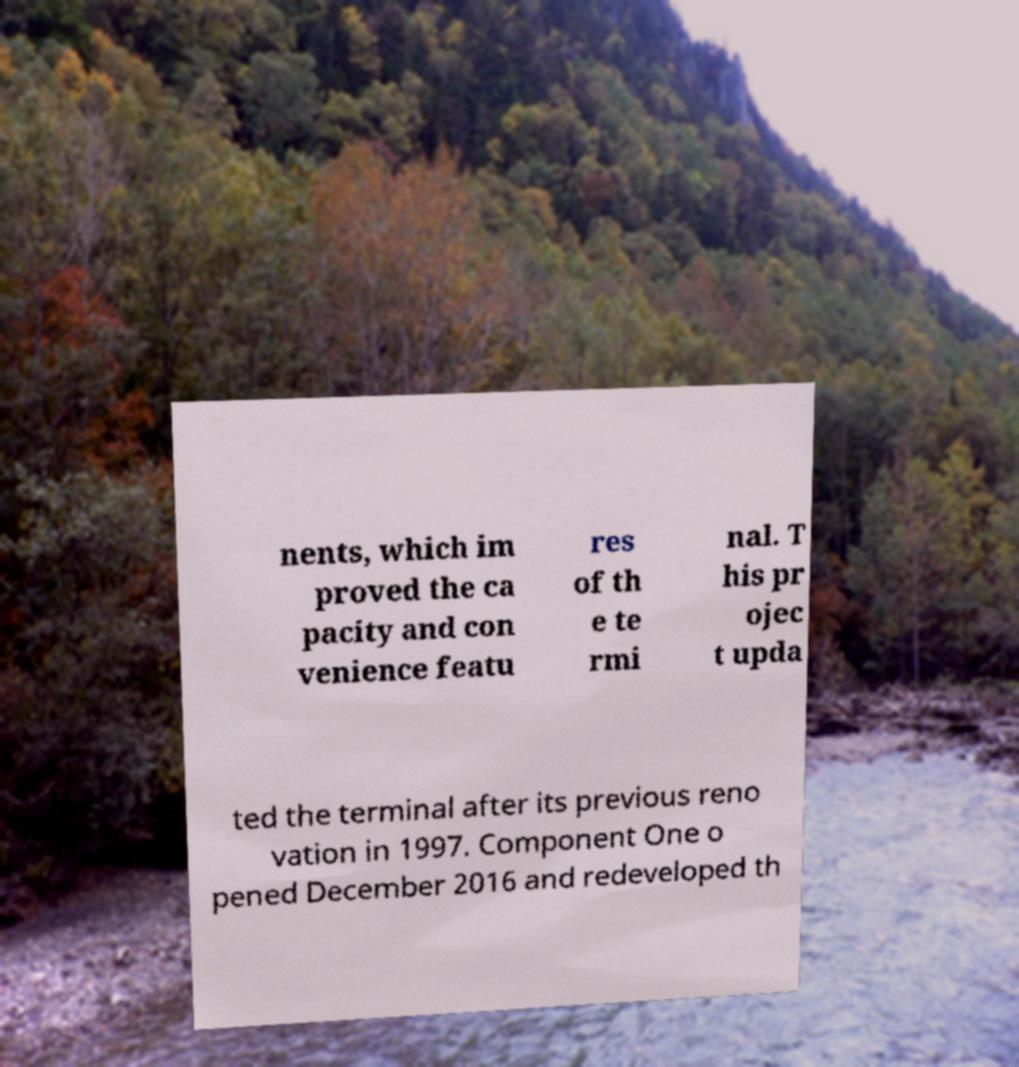What messages or text are displayed in this image? I need them in a readable, typed format. nents, which im proved the ca pacity and con venience featu res of th e te rmi nal. T his pr ojec t upda ted the terminal after its previous reno vation in 1997. Component One o pened December 2016 and redeveloped th 